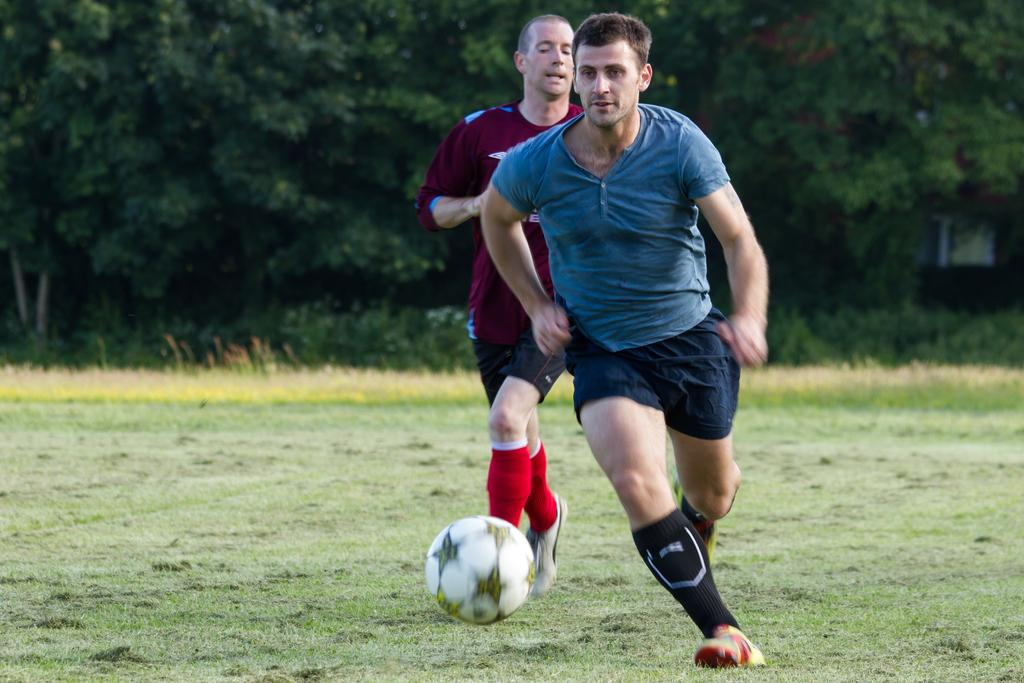How many people are in the image? There are two men in the image. What are the men doing in the image? The men are running on the ground. What are they running for? They are running for a ball. What can be seen in the background of the image? There are trees and grass in the background of the image. What type of offer is the man making to the tree in the image? There is no offer being made in the image, as the men are running for a ball and there are no interactions with the trees. 